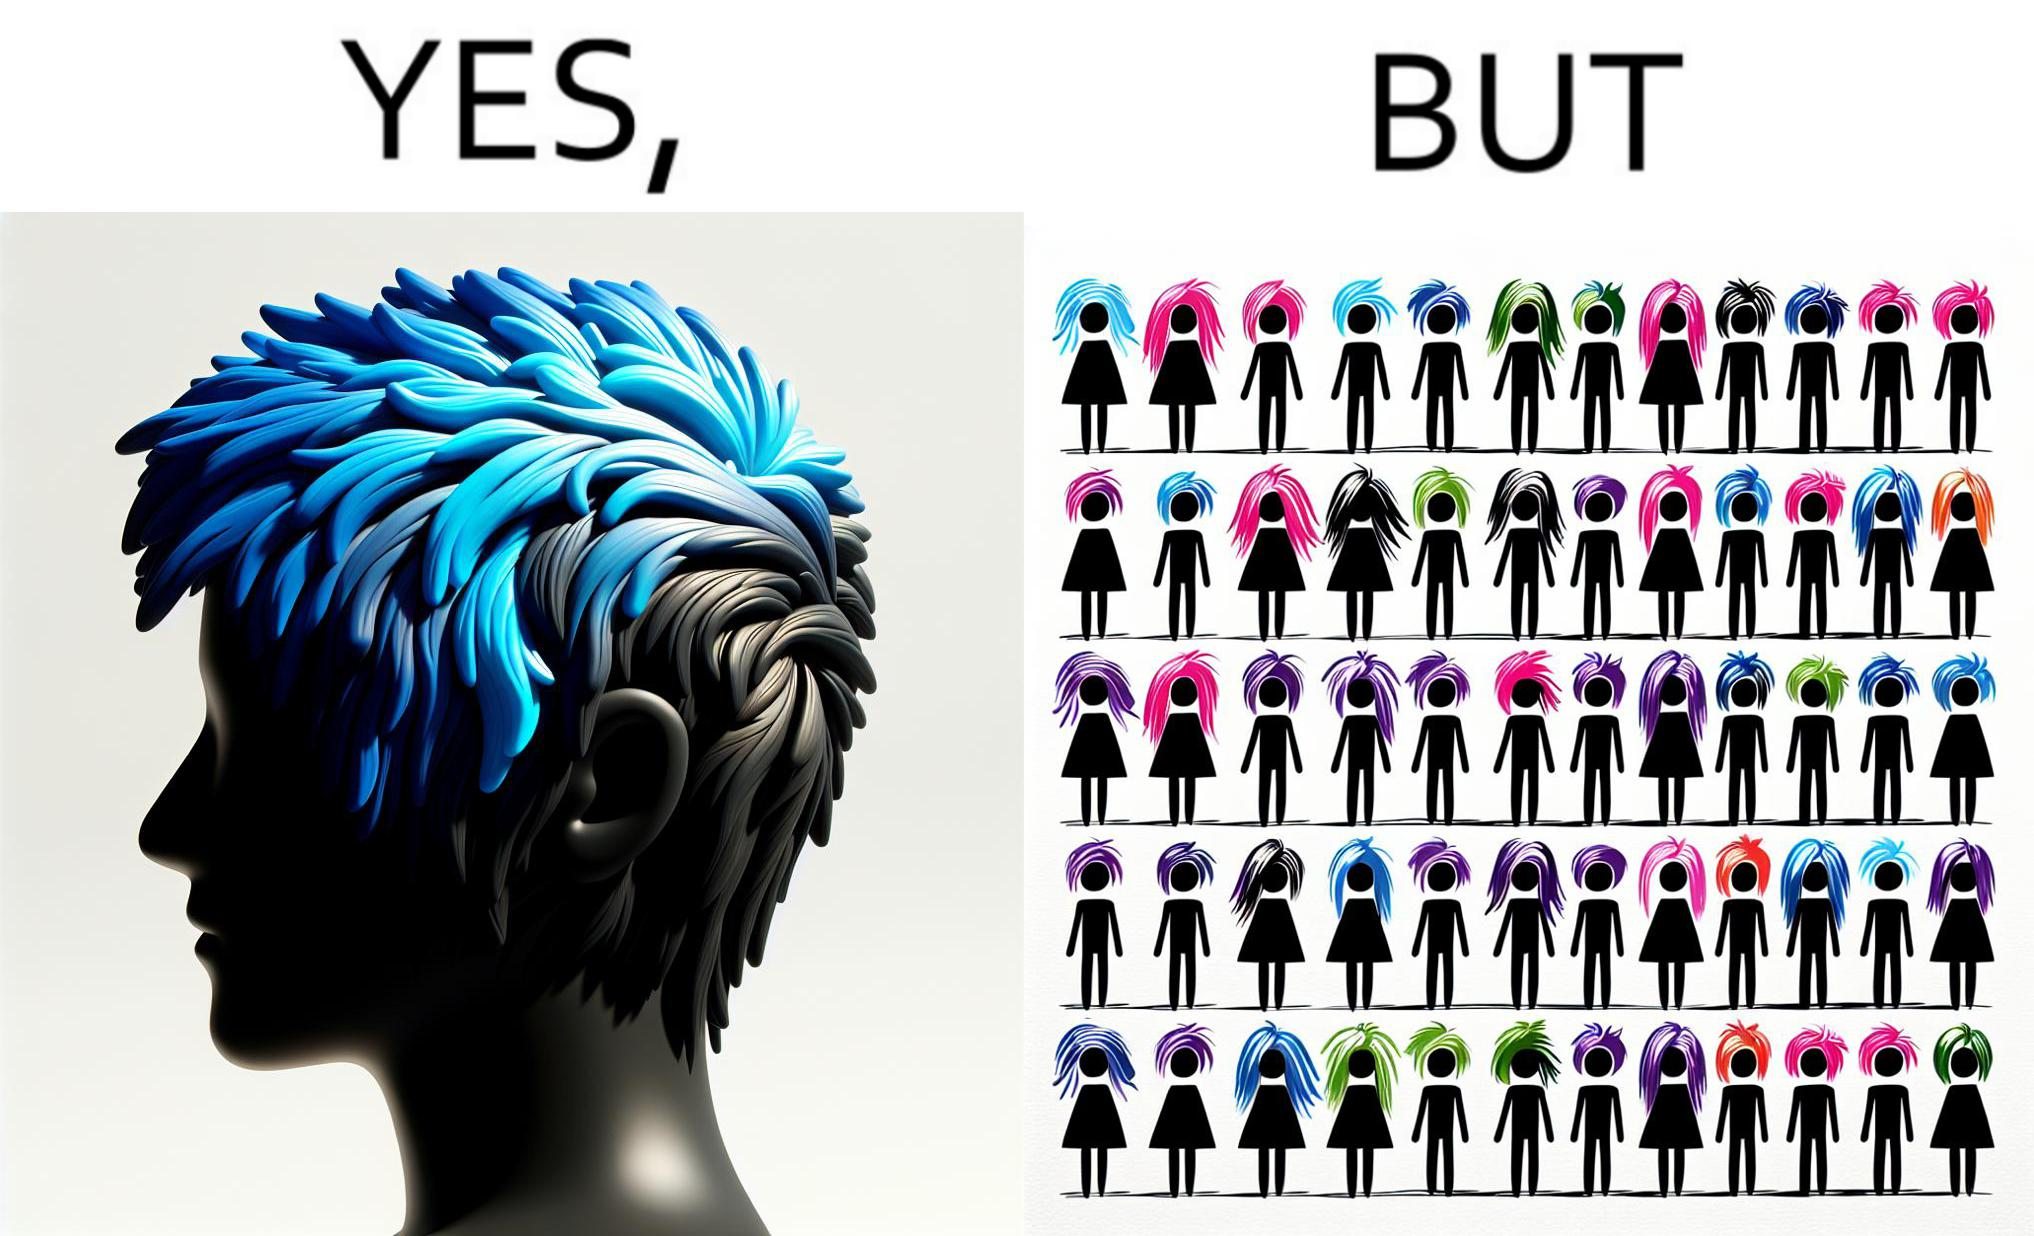Describe the contrast between the left and right parts of this image. In the left part of the image: a person with hair dyed blue. In the right part of the image: a group of people having hair dyed in different colors. 